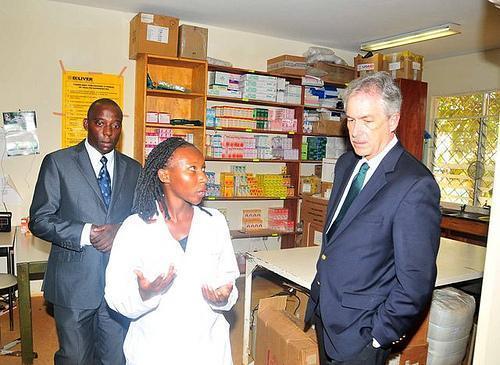How many people are wearing dark suits?
Give a very brief answer. 2. 